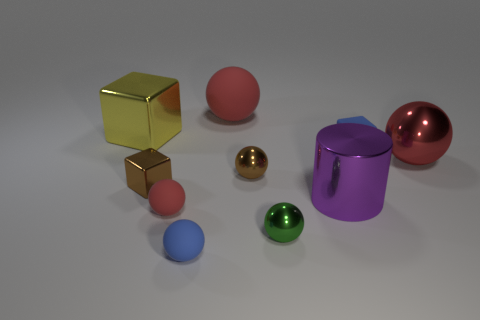How big is the matte sphere behind the large metallic object on the left side of the metallic cube that is in front of the large red shiny object?
Offer a very short reply. Large. There is a shiny thing that is the same color as the big matte ball; what is its size?
Offer a very short reply. Large. What size is the red sphere that is both on the right side of the tiny blue matte ball and in front of the large yellow shiny block?
Offer a very short reply. Large. What material is the small ball that is the same color as the big metal ball?
Your answer should be very brief. Rubber. The blue rubber thing that is the same shape as the big yellow object is what size?
Ensure brevity in your answer.  Small. Are the tiny blue thing that is to the right of the purple cylinder and the tiny green object made of the same material?
Your answer should be compact. No. What color is the other big metallic object that is the same shape as the green thing?
Your response must be concise. Red. What number of other objects are there of the same color as the small metallic block?
Your answer should be very brief. 1. Do the metallic thing that is on the left side of the small metal block and the rubber thing that is to the right of the green metal object have the same shape?
Your answer should be compact. Yes. How many blocks are either big red metal objects or yellow objects?
Keep it short and to the point. 1. 